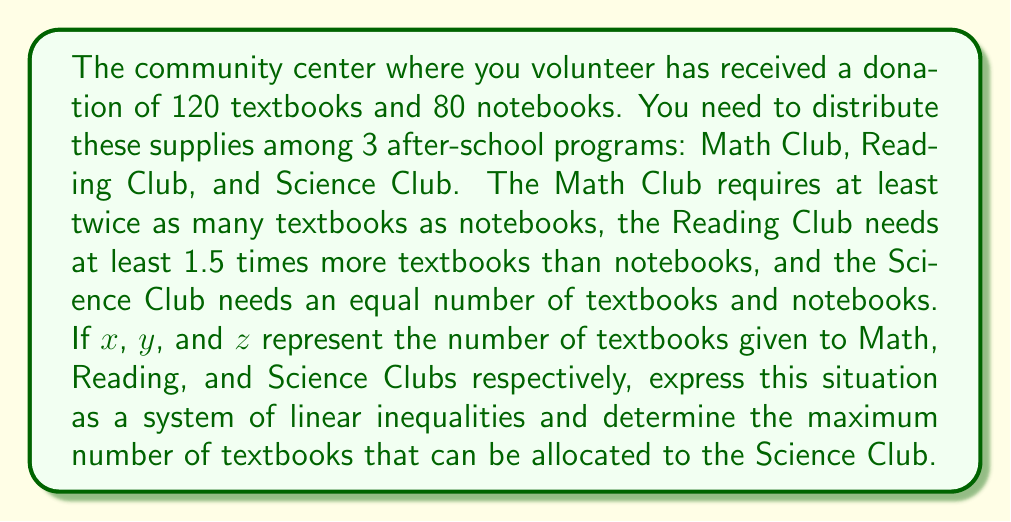Could you help me with this problem? Let's approach this step-by-step:

1) First, let's define our variables:
   $x$ = textbooks for Math Club
   $y$ = textbooks for Reading Club
   $z$ = textbooks for Science Club

2) Now, we can set up our constraints:
   Total textbooks: $x + y + z \leq 120$
   Total notebooks: $\frac{x}{2} + \frac{2y}{3} + z \leq 80$

3) The inequality for Math Club (twice as many textbooks as notebooks):
   $x \geq 2(\frac{x}{2}) \Rightarrow$ This is always true, so no additional constraint.

4) The inequality for Reading Club (1.5 times more textbooks than notebooks):
   $y \geq 1.5(\frac{2y}{3}) \Rightarrow y \geq y$, which is always true.

5) The inequality for Science Club (equal number of textbooks and notebooks):
   $z \leq 80 - (\frac{x}{2} + \frac{2y}{3})$

6) We want to maximize $z$, so we need to minimize $\frac{x}{2} + \frac{2y}{3}$

7) Given that $x + y + z \leq 120$, we can substitute $z$ with $80 - (\frac{x}{2} + \frac{2y}{3})$:
   $x + y + 80 - (\frac{x}{2} + \frac{2y}{3}) \leq 120$
   $\frac{x}{2} + \frac{y}{3} \geq 40$

8) To maximize $z$, we need $\frac{x}{2} + \frac{y}{3} = 40$

9) Substituting this back into the equation for $z$:
   $z = 80 - 40 = 40$

Therefore, the maximum number of textbooks that can be allocated to the Science Club is 40.
Answer: 40 textbooks 